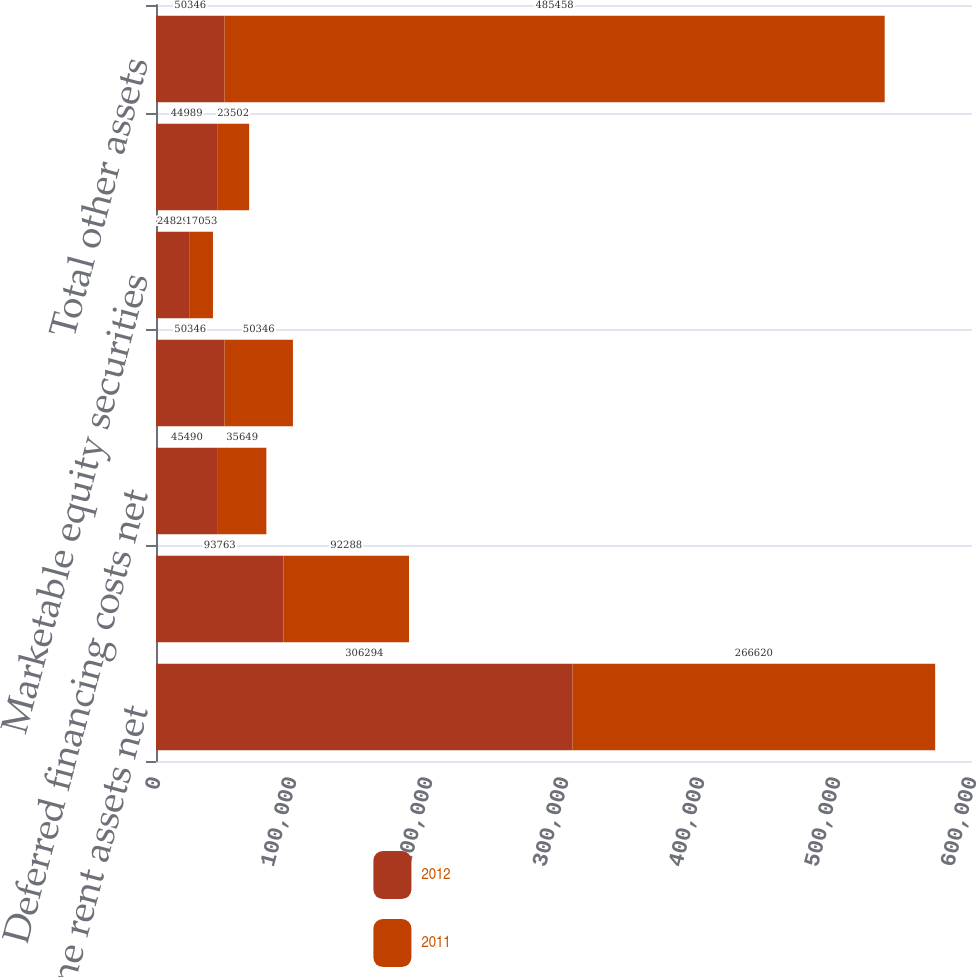Convert chart. <chart><loc_0><loc_0><loc_500><loc_500><stacked_bar_chart><ecel><fcel>Straight-line rent assets net<fcel>Leasing costs net<fcel>Deferred financing costs net<fcel>Goodwill<fcel>Marketable equity securities<fcel>Other (2)(3)<fcel>Total other assets<nl><fcel>2012<fcel>306294<fcel>93763<fcel>45490<fcel>50346<fcel>24829<fcel>44989<fcel>50346<nl><fcel>2011<fcel>266620<fcel>92288<fcel>35649<fcel>50346<fcel>17053<fcel>23502<fcel>485458<nl></chart> 